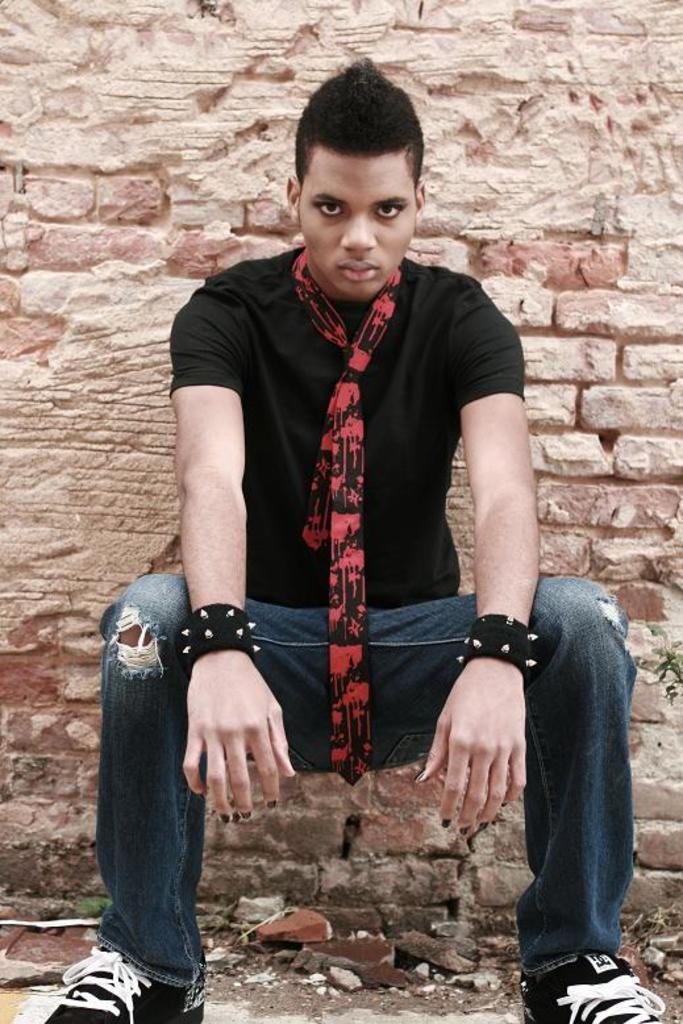Describe this image in one or two sentences. In this image I can see a person wearing black t shirt, red and black scarf and blue jeans is sitting. In the background I can see the wall which is made up bricks which is cream in color. 